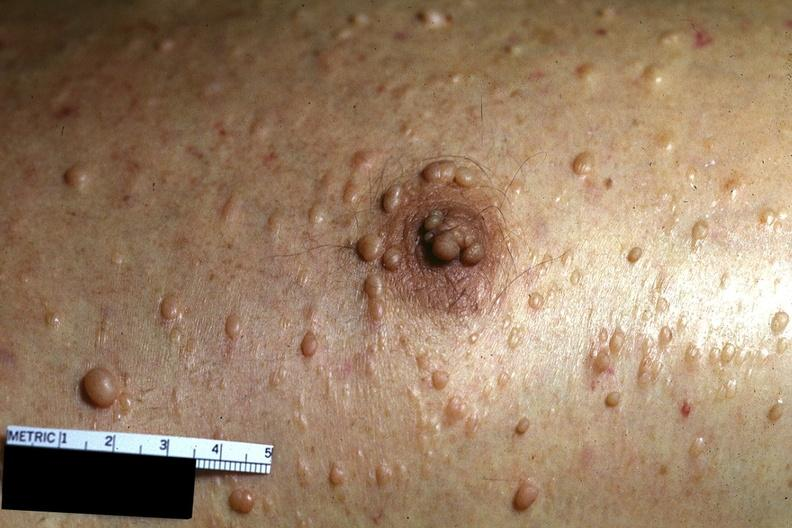where is this?
Answer the question using a single word or phrase. Skin 